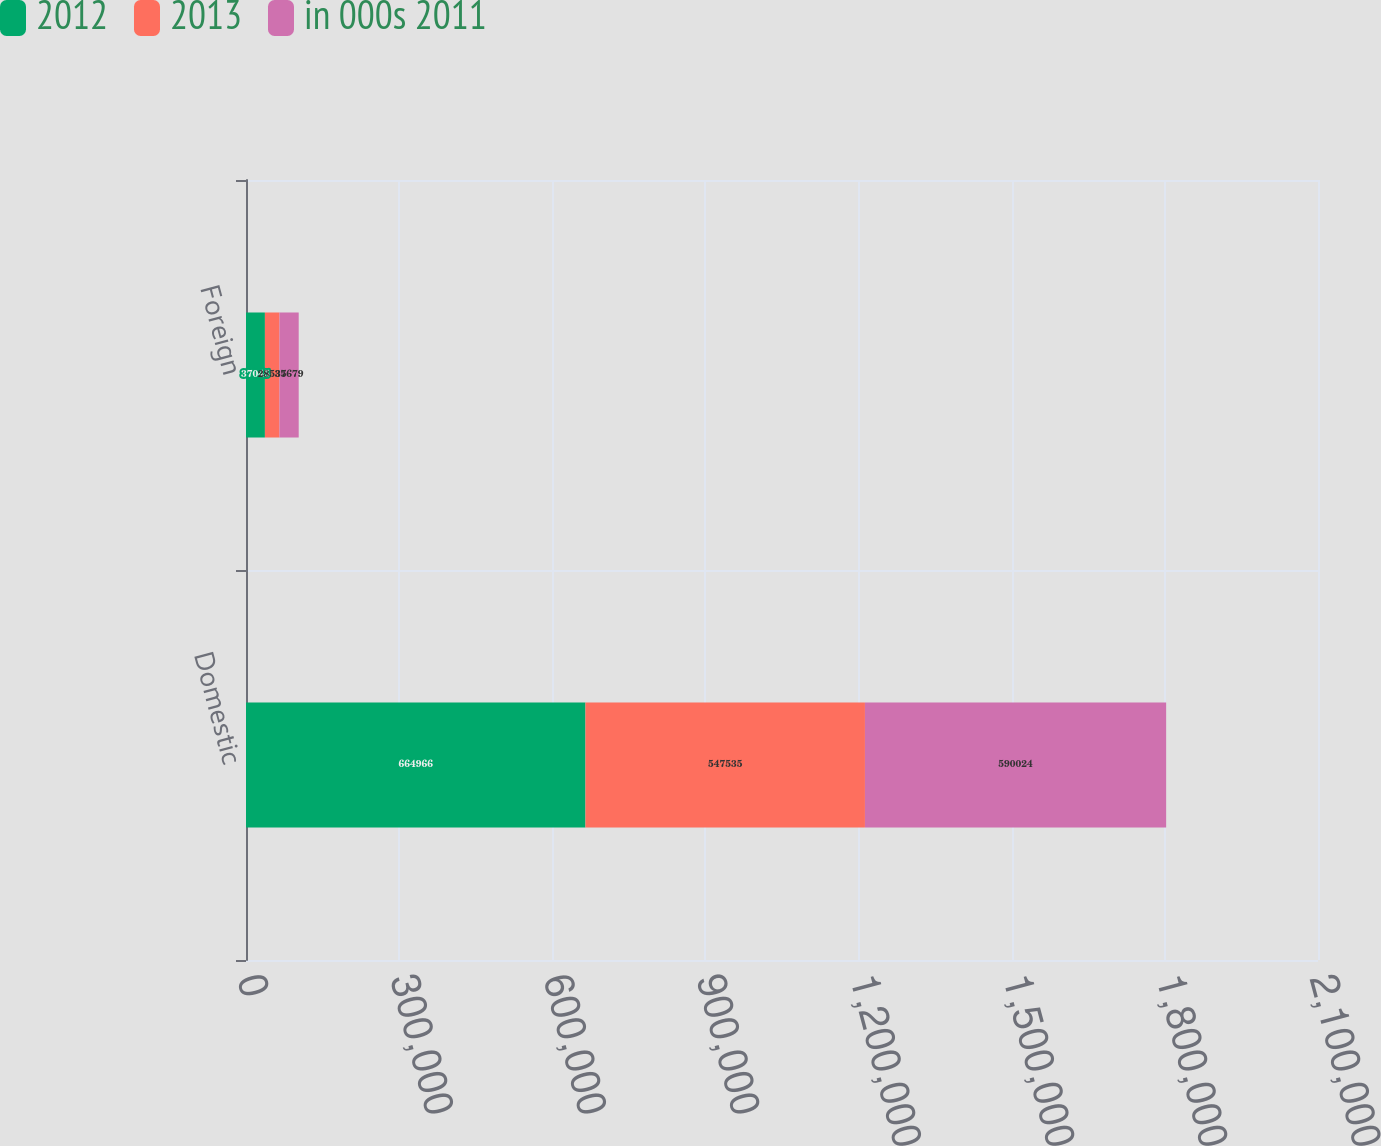<chart> <loc_0><loc_0><loc_500><loc_500><stacked_bar_chart><ecel><fcel>Domestic<fcel>Foreign<nl><fcel>2012<fcel>664966<fcel>37045<nl><fcel>2013<fcel>547535<fcel>28535<nl><fcel>in 000s 2011<fcel>590024<fcel>37679<nl></chart> 